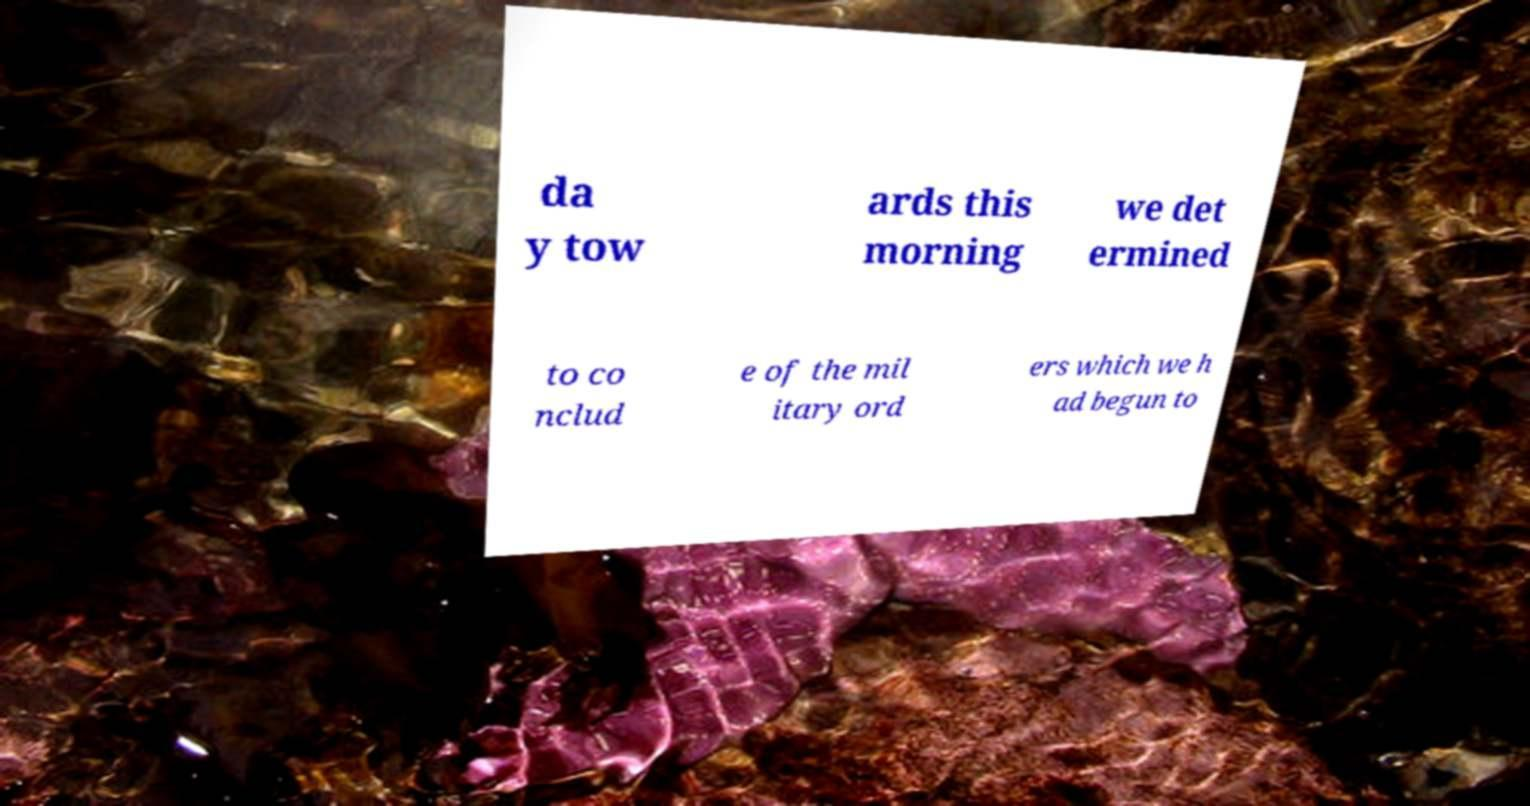Could you extract and type out the text from this image? da y tow ards this morning we det ermined to co nclud e of the mil itary ord ers which we h ad begun to 